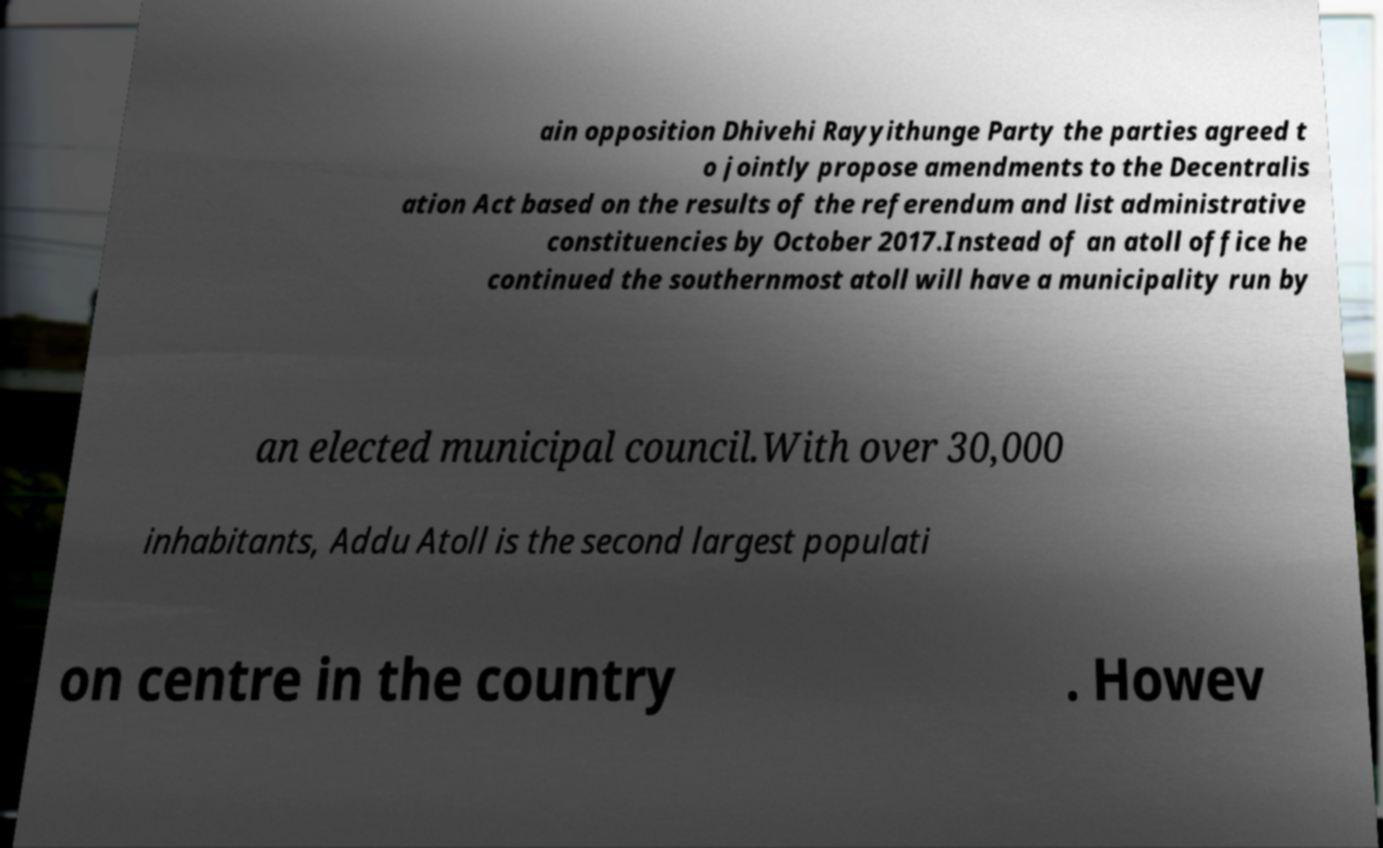Please identify and transcribe the text found in this image. ain opposition Dhivehi Rayyithunge Party the parties agreed t o jointly propose amendments to the Decentralis ation Act based on the results of the referendum and list administrative constituencies by October 2017.Instead of an atoll office he continued the southernmost atoll will have a municipality run by an elected municipal council.With over 30,000 inhabitants, Addu Atoll is the second largest populati on centre in the country . Howev 